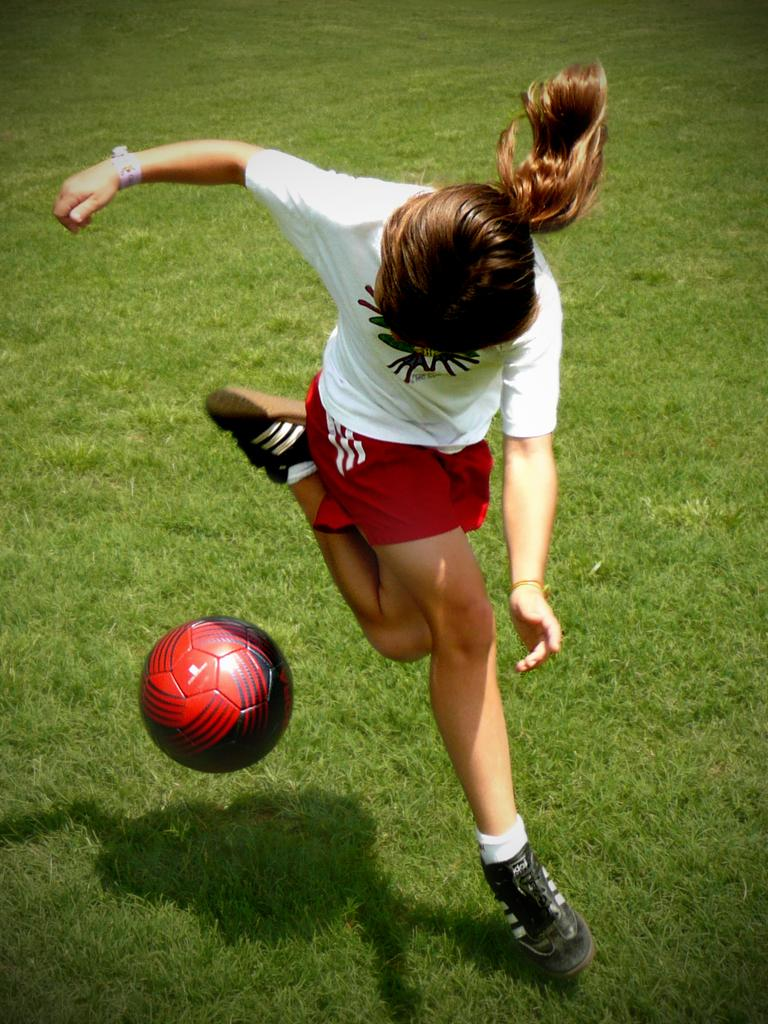Who is the main subject in the image? There is a girl in the image. What is the girl doing in the image? The girl is playing football. What is the surface beneath the girl's feet in the image? There is green grass at the bottom of the image. What object is the girl playing with? There is a football in the image. What is the girl wearing in the image? The girl is wearing a white and red color sports dress. Can you see the girl going on a voyage with her friends in the image? There is no indication of a voyage or the girl's friends in the image; it only shows the girl playing football on green grass. 